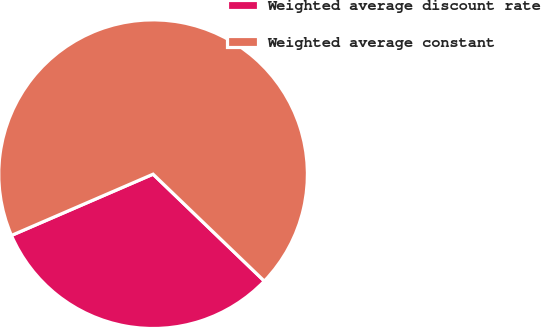<chart> <loc_0><loc_0><loc_500><loc_500><pie_chart><fcel>Weighted average discount rate<fcel>Weighted average constant<nl><fcel>31.32%<fcel>68.68%<nl></chart> 